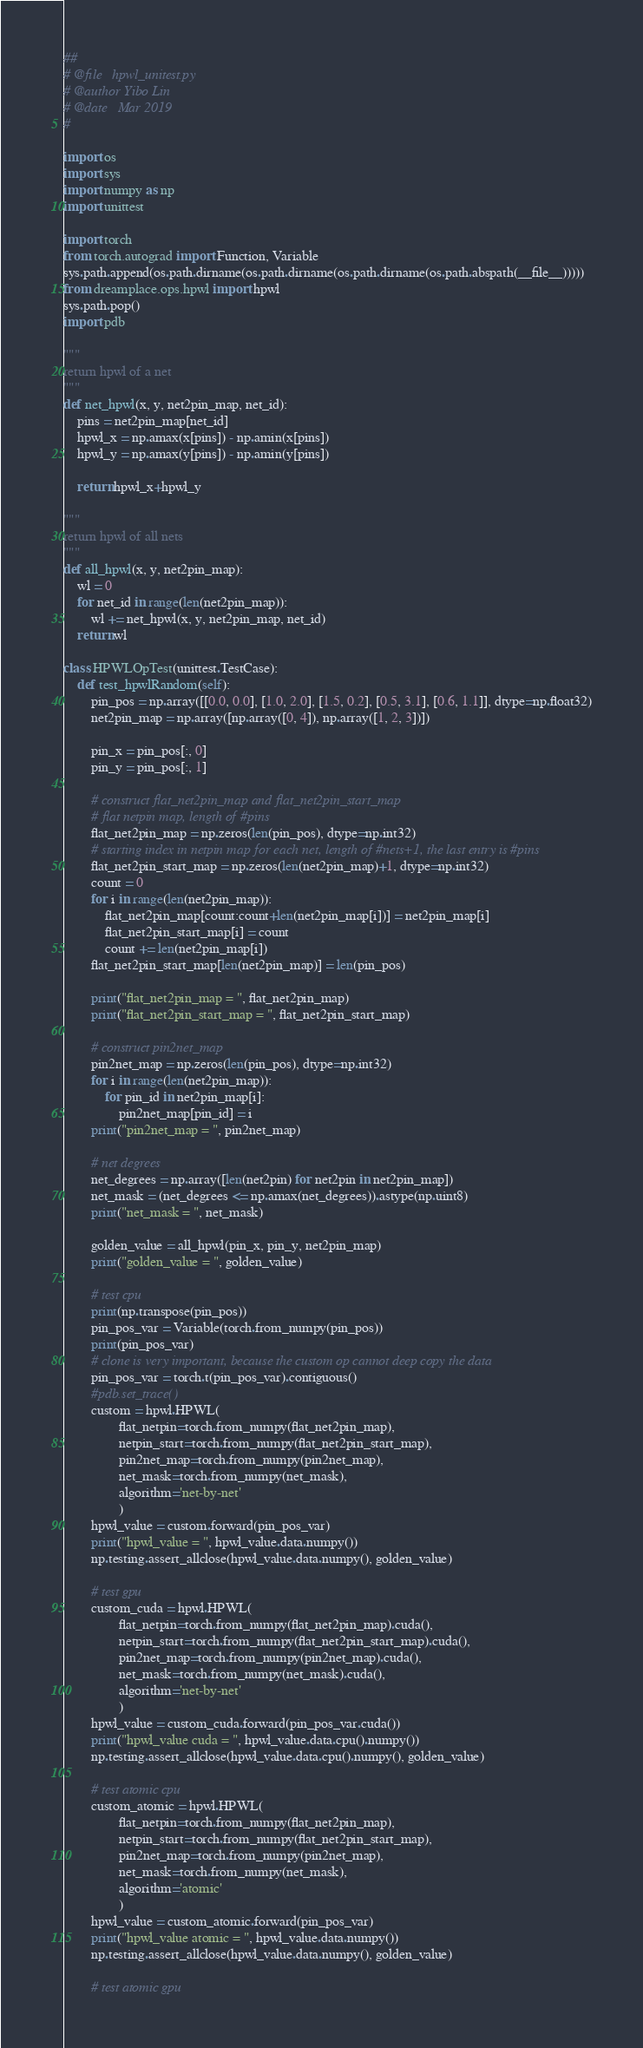<code> <loc_0><loc_0><loc_500><loc_500><_Python_>##
# @file   hpwl_unitest.py
# @author Yibo Lin
# @date   Mar 2019
#

import os 
import sys
import numpy as np
import unittest

import torch
from torch.autograd import Function, Variable
sys.path.append(os.path.dirname(os.path.dirname(os.path.dirname(os.path.abspath(__file__)))))
from dreamplace.ops.hpwl import hpwl
sys.path.pop()
import pdb 

"""
return hpwl of a net 
"""
def net_hpwl(x, y, net2pin_map, net_id): 
    pins = net2pin_map[net_id]
    hpwl_x = np.amax(x[pins]) - np.amin(x[pins])
    hpwl_y = np.amax(y[pins]) - np.amin(y[pins])

    return hpwl_x+hpwl_y

"""
return hpwl of all nets
"""
def all_hpwl(x, y, net2pin_map):
    wl = 0
    for net_id in range(len(net2pin_map)):
        wl += net_hpwl(x, y, net2pin_map, net_id)
    return wl 

class HPWLOpTest(unittest.TestCase):
    def test_hpwlRandom(self):
        pin_pos = np.array([[0.0, 0.0], [1.0, 2.0], [1.5, 0.2], [0.5, 3.1], [0.6, 1.1]], dtype=np.float32)
        net2pin_map = np.array([np.array([0, 4]), np.array([1, 2, 3])])

        pin_x = pin_pos[:, 0]
        pin_y = pin_pos[:, 1]

        # construct flat_net2pin_map and flat_net2pin_start_map
        # flat netpin map, length of #pins
        flat_net2pin_map = np.zeros(len(pin_pos), dtype=np.int32)
        # starting index in netpin map for each net, length of #nets+1, the last entry is #pins  
        flat_net2pin_start_map = np.zeros(len(net2pin_map)+1, dtype=np.int32)
        count = 0
        for i in range(len(net2pin_map)):
            flat_net2pin_map[count:count+len(net2pin_map[i])] = net2pin_map[i]
            flat_net2pin_start_map[i] = count 
            count += len(net2pin_map[i])
        flat_net2pin_start_map[len(net2pin_map)] = len(pin_pos)
        
        print("flat_net2pin_map = ", flat_net2pin_map)
        print("flat_net2pin_start_map = ", flat_net2pin_start_map)

        # construct pin2net_map 
        pin2net_map = np.zeros(len(pin_pos), dtype=np.int32)
        for i in range(len(net2pin_map)):
            for pin_id in net2pin_map[i]:
                pin2net_map[pin_id] = i 
        print("pin2net_map = ", pin2net_map)

        # net degrees 
        net_degrees = np.array([len(net2pin) for net2pin in net2pin_map])
        net_mask = (net_degrees <= np.amax(net_degrees)).astype(np.uint8)
        print("net_mask = ", net_mask)

        golden_value = all_hpwl(pin_x, pin_y, net2pin_map)
        print("golden_value = ", golden_value)

        # test cpu 
        print(np.transpose(pin_pos))
        pin_pos_var = Variable(torch.from_numpy(pin_pos))
        print(pin_pos_var)
        # clone is very important, because the custom op cannot deep copy the data 
        pin_pos_var = torch.t(pin_pos_var).contiguous()
        #pdb.set_trace()
        custom = hpwl.HPWL(
                flat_netpin=torch.from_numpy(flat_net2pin_map), 
                netpin_start=torch.from_numpy(flat_net2pin_start_map),
                pin2net_map=torch.from_numpy(pin2net_map), 
                net_mask=torch.from_numpy(net_mask), 
                algorithm='net-by-net'
                )
        hpwl_value = custom.forward(pin_pos_var)
        print("hpwl_value = ", hpwl_value.data.numpy())
        np.testing.assert_allclose(hpwl_value.data.numpy(), golden_value)

        # test gpu 
        custom_cuda = hpwl.HPWL(
                flat_netpin=torch.from_numpy(flat_net2pin_map).cuda(), 
                netpin_start=torch.from_numpy(flat_net2pin_start_map).cuda(),
                pin2net_map=torch.from_numpy(pin2net_map).cuda(), 
                net_mask=torch.from_numpy(net_mask).cuda(), 
                algorithm='net-by-net'
                )
        hpwl_value = custom_cuda.forward(pin_pos_var.cuda())
        print("hpwl_value cuda = ", hpwl_value.data.cpu().numpy())
        np.testing.assert_allclose(hpwl_value.data.cpu().numpy(), golden_value)

        # test atomic cpu 
        custom_atomic = hpwl.HPWL(
                flat_netpin=torch.from_numpy(flat_net2pin_map), 
                netpin_start=torch.from_numpy(flat_net2pin_start_map),
                pin2net_map=torch.from_numpy(pin2net_map), 
                net_mask=torch.from_numpy(net_mask), 
                algorithm='atomic'
                )
        hpwl_value = custom_atomic.forward(pin_pos_var)
        print("hpwl_value atomic = ", hpwl_value.data.numpy())
        np.testing.assert_allclose(hpwl_value.data.numpy(), golden_value)

        # test atomic gpu </code> 